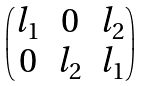<formula> <loc_0><loc_0><loc_500><loc_500>\begin{pmatrix} l _ { 1 } & 0 & l _ { 2 } \\ 0 & l _ { 2 } & l _ { 1 } \\ \end{pmatrix}</formula> 